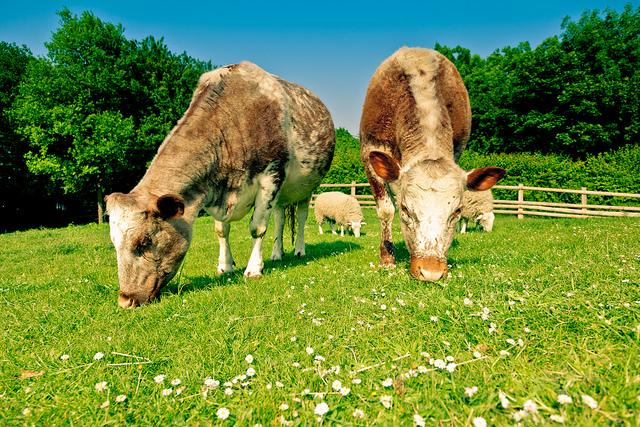What color is the grass?
Answer briefly. Green. What does the cow's milk taste like?
Keep it brief. Milk. What do these animals eat?
Concise answer only. Grass. 